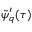Convert formula to latex. <formula><loc_0><loc_0><loc_500><loc_500>\tilde { \psi } _ { q } ^ { \prime } ( \tau )</formula> 